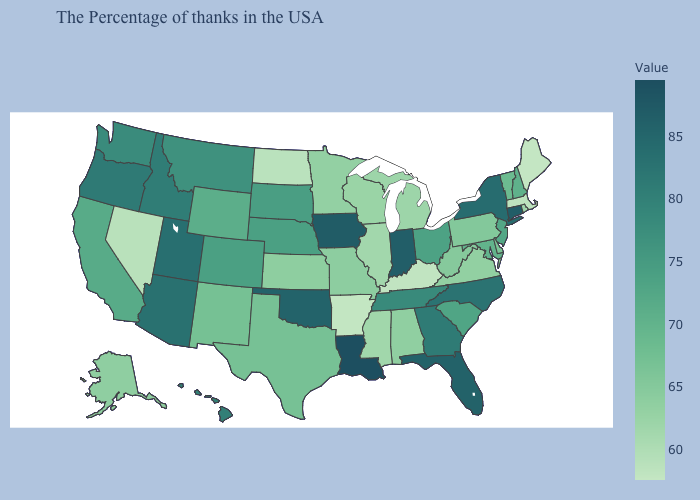Which states have the lowest value in the West?
Short answer required. Nevada. Does California have a higher value than Massachusetts?
Short answer required. Yes. Which states have the lowest value in the USA?
Give a very brief answer. Maine. Among the states that border Illinois , which have the highest value?
Be succinct. Iowa. Does Montana have the lowest value in the West?
Quick response, please. No. Among the states that border Kansas , which have the lowest value?
Short answer required. Missouri. Does Louisiana have the highest value in the USA?
Write a very short answer. Yes. 